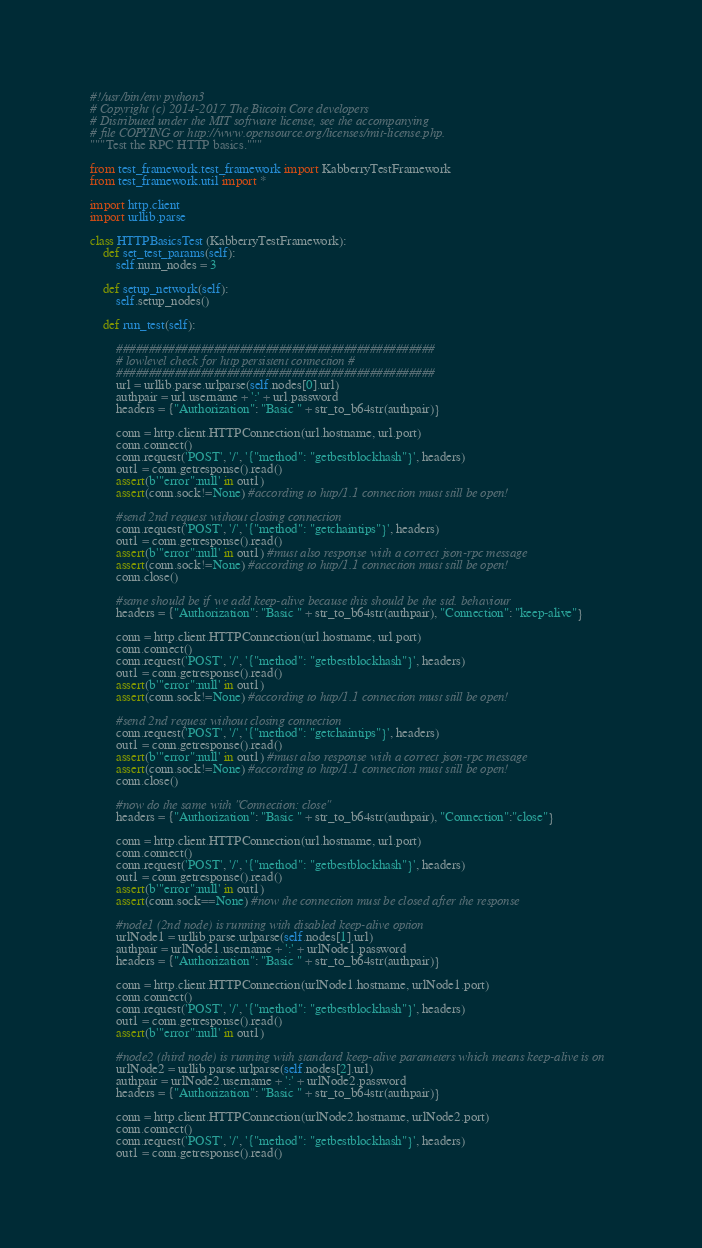Convert code to text. <code><loc_0><loc_0><loc_500><loc_500><_Python_>#!/usr/bin/env python3
# Copyright (c) 2014-2017 The Bitcoin Core developers
# Distributed under the MIT software license, see the accompanying
# file COPYING or http://www.opensource.org/licenses/mit-license.php.
"""Test the RPC HTTP basics."""

from test_framework.test_framework import KabberryTestFramework
from test_framework.util import *

import http.client
import urllib.parse

class HTTPBasicsTest (KabberryTestFramework):
    def set_test_params(self):
        self.num_nodes = 3

    def setup_network(self):
        self.setup_nodes()

    def run_test(self):

        #################################################
        # lowlevel check for http persistent connection #
        #################################################
        url = urllib.parse.urlparse(self.nodes[0].url)
        authpair = url.username + ':' + url.password
        headers = {"Authorization": "Basic " + str_to_b64str(authpair)}

        conn = http.client.HTTPConnection(url.hostname, url.port)
        conn.connect()
        conn.request('POST', '/', '{"method": "getbestblockhash"}', headers)
        out1 = conn.getresponse().read()
        assert(b'"error":null' in out1)
        assert(conn.sock!=None) #according to http/1.1 connection must still be open!

        #send 2nd request without closing connection
        conn.request('POST', '/', '{"method": "getchaintips"}', headers)
        out1 = conn.getresponse().read()
        assert(b'"error":null' in out1) #must also response with a correct json-rpc message
        assert(conn.sock!=None) #according to http/1.1 connection must still be open!
        conn.close()

        #same should be if we add keep-alive because this should be the std. behaviour
        headers = {"Authorization": "Basic " + str_to_b64str(authpair), "Connection": "keep-alive"}

        conn = http.client.HTTPConnection(url.hostname, url.port)
        conn.connect()
        conn.request('POST', '/', '{"method": "getbestblockhash"}', headers)
        out1 = conn.getresponse().read()
        assert(b'"error":null' in out1)
        assert(conn.sock!=None) #according to http/1.1 connection must still be open!

        #send 2nd request without closing connection
        conn.request('POST', '/', '{"method": "getchaintips"}', headers)
        out1 = conn.getresponse().read()
        assert(b'"error":null' in out1) #must also response with a correct json-rpc message
        assert(conn.sock!=None) #according to http/1.1 connection must still be open!
        conn.close()

        #now do the same with "Connection: close"
        headers = {"Authorization": "Basic " + str_to_b64str(authpair), "Connection":"close"}

        conn = http.client.HTTPConnection(url.hostname, url.port)
        conn.connect()
        conn.request('POST', '/', '{"method": "getbestblockhash"}', headers)
        out1 = conn.getresponse().read()
        assert(b'"error":null' in out1)
        assert(conn.sock==None) #now the connection must be closed after the response

        #node1 (2nd node) is running with disabled keep-alive option
        urlNode1 = urllib.parse.urlparse(self.nodes[1].url)
        authpair = urlNode1.username + ':' + urlNode1.password
        headers = {"Authorization": "Basic " + str_to_b64str(authpair)}

        conn = http.client.HTTPConnection(urlNode1.hostname, urlNode1.port)
        conn.connect()
        conn.request('POST', '/', '{"method": "getbestblockhash"}', headers)
        out1 = conn.getresponse().read()
        assert(b'"error":null' in out1)

        #node2 (third node) is running with standard keep-alive parameters which means keep-alive is on
        urlNode2 = urllib.parse.urlparse(self.nodes[2].url)
        authpair = urlNode2.username + ':' + urlNode2.password
        headers = {"Authorization": "Basic " + str_to_b64str(authpair)}

        conn = http.client.HTTPConnection(urlNode2.hostname, urlNode2.port)
        conn.connect()
        conn.request('POST', '/', '{"method": "getbestblockhash"}', headers)
        out1 = conn.getresponse().read()</code> 